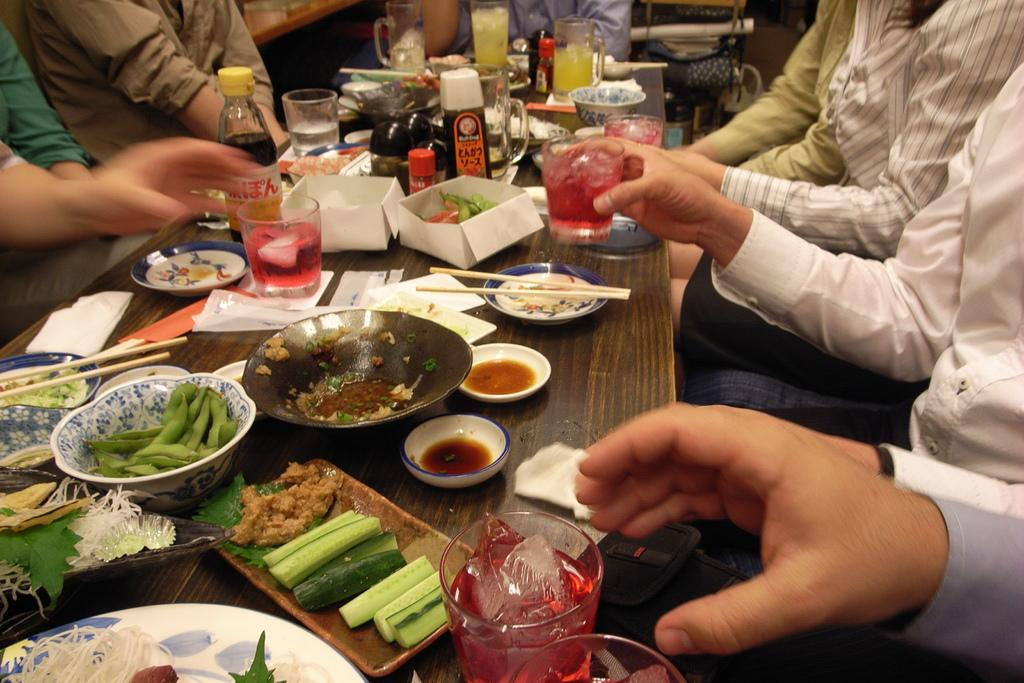What are the people in the image doing? There is a group of people sitting around a table. What objects can be seen on the table? There are bowls, plates, glasses, chopsticks, a bottle, and tissues on the table. What type of food is present on the table? There is food on the table. What utensils are available for eating the food? Chopsticks are on the table. What type of grain is being harvested by the wrist in the image? There is no grain or wrist present in the image. 